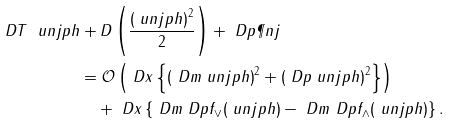Convert formula to latex. <formula><loc_0><loc_0><loc_500><loc_500>\ D T \ u n j p h & + D \left ( \frac { \left ( \ u n j p h \right ) ^ { 2 } } { 2 } \right ) + \ D p \P n j \\ & = \mathcal { O } \left ( \ D x \left \{ \left ( \ D m \ u n j p h \right ) ^ { 2 } + \left ( \ D p \ u n j p h \right ) ^ { 2 } \right \} \right ) \\ & \quad + \ D x \left \{ \ D m \ D p f _ { \vee } ( \ u n j p h ) - \ D m \ D p f _ { \wedge } ( \ u n j p h ) \right \} .</formula> 